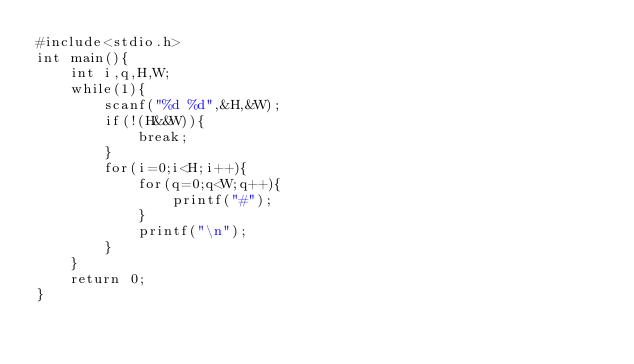<code> <loc_0><loc_0><loc_500><loc_500><_C_>#include<stdio.h>
int main(){
    int i,q,H,W;
    while(1){
        scanf("%d %d",&H,&W);
        if(!(H&&W)){
            break;
        }
        for(i=0;i<H;i++){
            for(q=0;q<W;q++){
                printf("#");
            }
            printf("\n");
        }
    }
    return 0;
}</code> 